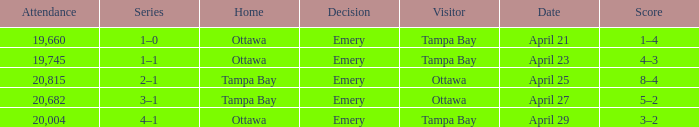What is the date of the game when attendance is more than 20,682? April 25. 